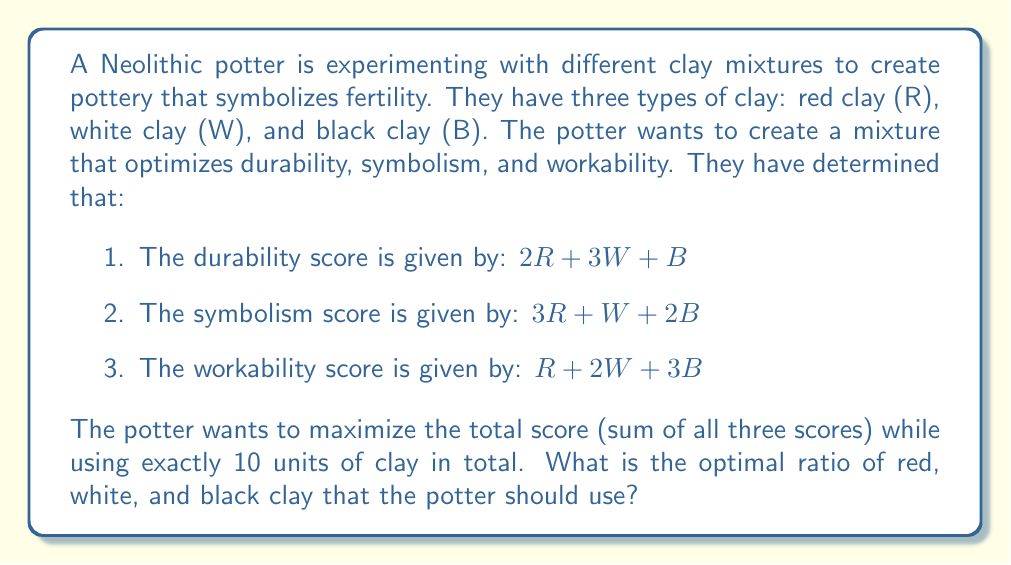Can you solve this math problem? Let's approach this step-by-step using a system of equations:

1) First, we need to set up our objective function. We want to maximize the total score:

   $\text{Total Score} = (2R + 3W + B) + (3R + W + 2B) + (R + 2W + 3B)$
                       $= 6R + 6W + 6B$

2) We have the constraint that the total amount of clay used must be 10 units:

   $R + W + B = 10$

3) We can set up a system of equations using the method of Lagrange multipliers:

   $\begin{cases}
   6 - \lambda = 0 \\
   6 - \lambda = 0 \\
   6 - \lambda = 0 \\
   R + W + B = 10
   \end{cases}$

4) From the first three equations, we can see that $\lambda = 6$ for all variables. This means that $R = W = B$ to maximize the score.

5) Substituting this into our constraint equation:

   $R + R + R = 10$
   $3R = 10$
   $R = \frac{10}{3}$

6) Since $R = W = B$, each type of clay should be used in equal amounts of $\frac{10}{3}$ units.

7) To express this as a ratio, we can simplify $\frac{10}{3} : \frac{10}{3} : \frac{10}{3}$ to $1:1:1$.
Answer: The optimal ratio of red clay to white clay to black clay is $1:1:1$. 